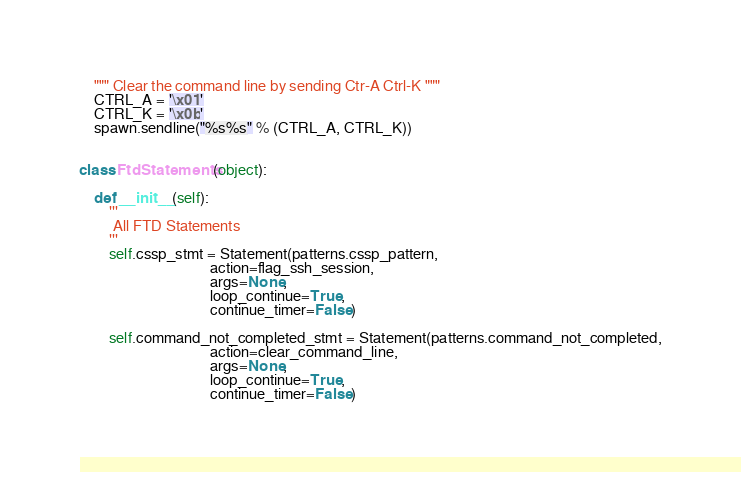Convert code to text. <code><loc_0><loc_0><loc_500><loc_500><_Python_>    """ Clear the command line by sending Ctr-A Ctrl-K """
    CTRL_A = '\x01'
    CTRL_K = '\x0b'
    spawn.sendline("%s%s" % (CTRL_A, CTRL_K))


class FtdStatements(object):

    def __init__(self):
        '''
         All FTD Statements
        '''
        self.cssp_stmt = Statement(patterns.cssp_pattern,
                                   action=flag_ssh_session,
                                   args=None,
                                   loop_continue=True,
                                   continue_timer=False)

        self.command_not_completed_stmt = Statement(patterns.command_not_completed,
                                   action=clear_command_line,
                                   args=None,
                                   loop_continue=True,
                                   continue_timer=False)
</code> 